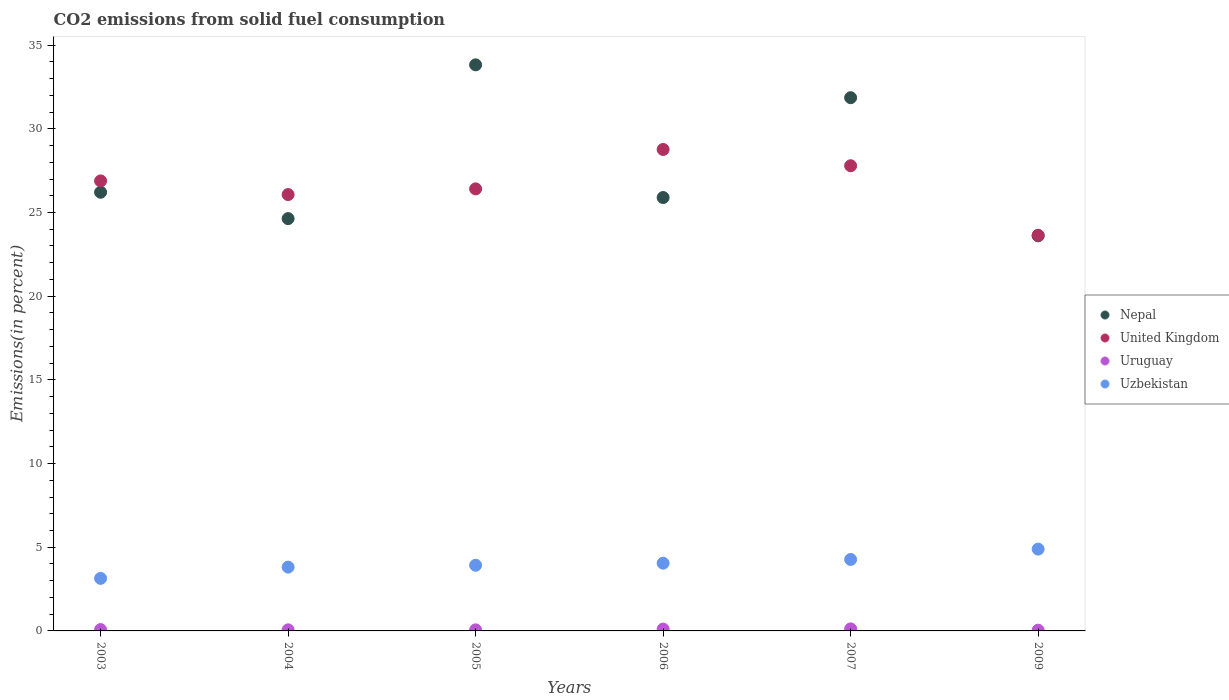Is the number of dotlines equal to the number of legend labels?
Your answer should be compact. Yes. What is the total CO2 emitted in Uzbekistan in 2005?
Your response must be concise. 3.92. Across all years, what is the maximum total CO2 emitted in Uruguay?
Give a very brief answer. 0.12. Across all years, what is the minimum total CO2 emitted in United Kingdom?
Ensure brevity in your answer.  23.64. In which year was the total CO2 emitted in United Kingdom maximum?
Keep it short and to the point. 2006. What is the total total CO2 emitted in Nepal in the graph?
Make the answer very short. 166.03. What is the difference between the total CO2 emitted in United Kingdom in 2003 and that in 2007?
Your answer should be very brief. -0.91. What is the difference between the total CO2 emitted in United Kingdom in 2006 and the total CO2 emitted in Uzbekistan in 2003?
Offer a terse response. 25.63. What is the average total CO2 emitted in Uruguay per year?
Give a very brief answer. 0.08. In the year 2009, what is the difference between the total CO2 emitted in Uzbekistan and total CO2 emitted in Uruguay?
Your response must be concise. 4.84. In how many years, is the total CO2 emitted in United Kingdom greater than 25 %?
Offer a very short reply. 5. What is the ratio of the total CO2 emitted in United Kingdom in 2004 to that in 2006?
Give a very brief answer. 0.91. Is the total CO2 emitted in Uzbekistan in 2004 less than that in 2009?
Your response must be concise. Yes. What is the difference between the highest and the second highest total CO2 emitted in Uruguay?
Offer a terse response. 0.01. What is the difference between the highest and the lowest total CO2 emitted in Uruguay?
Your response must be concise. 0.08. In how many years, is the total CO2 emitted in Uruguay greater than the average total CO2 emitted in Uruguay taken over all years?
Keep it short and to the point. 2. Is it the case that in every year, the sum of the total CO2 emitted in United Kingdom and total CO2 emitted in Uruguay  is greater than the sum of total CO2 emitted in Uzbekistan and total CO2 emitted in Nepal?
Offer a very short reply. Yes. Is the total CO2 emitted in Uruguay strictly greater than the total CO2 emitted in Uzbekistan over the years?
Offer a terse response. No. Is the total CO2 emitted in Uzbekistan strictly less than the total CO2 emitted in Nepal over the years?
Your response must be concise. Yes. How many dotlines are there?
Keep it short and to the point. 4. How many years are there in the graph?
Your answer should be compact. 6. Does the graph contain any zero values?
Provide a short and direct response. No. What is the title of the graph?
Your answer should be very brief. CO2 emissions from solid fuel consumption. What is the label or title of the Y-axis?
Offer a terse response. Emissions(in percent). What is the Emissions(in percent) in Nepal in 2003?
Your answer should be very brief. 26.21. What is the Emissions(in percent) of United Kingdom in 2003?
Your response must be concise. 26.89. What is the Emissions(in percent) in Uruguay in 2003?
Give a very brief answer. 0.08. What is the Emissions(in percent) in Uzbekistan in 2003?
Provide a short and direct response. 3.14. What is the Emissions(in percent) of Nepal in 2004?
Give a very brief answer. 24.64. What is the Emissions(in percent) of United Kingdom in 2004?
Ensure brevity in your answer.  26.07. What is the Emissions(in percent) in Uruguay in 2004?
Your answer should be compact. 0.07. What is the Emissions(in percent) of Uzbekistan in 2004?
Provide a short and direct response. 3.81. What is the Emissions(in percent) of Nepal in 2005?
Your answer should be very brief. 33.82. What is the Emissions(in percent) of United Kingdom in 2005?
Provide a short and direct response. 26.41. What is the Emissions(in percent) in Uruguay in 2005?
Make the answer very short. 0.06. What is the Emissions(in percent) of Uzbekistan in 2005?
Provide a short and direct response. 3.92. What is the Emissions(in percent) of Nepal in 2006?
Your answer should be very brief. 25.9. What is the Emissions(in percent) in United Kingdom in 2006?
Give a very brief answer. 28.77. What is the Emissions(in percent) in Uruguay in 2006?
Provide a short and direct response. 0.11. What is the Emissions(in percent) in Uzbekistan in 2006?
Offer a terse response. 4.05. What is the Emissions(in percent) of Nepal in 2007?
Provide a succinct answer. 31.86. What is the Emissions(in percent) in United Kingdom in 2007?
Give a very brief answer. 27.79. What is the Emissions(in percent) in Uruguay in 2007?
Provide a short and direct response. 0.12. What is the Emissions(in percent) of Uzbekistan in 2007?
Your response must be concise. 4.27. What is the Emissions(in percent) in Nepal in 2009?
Keep it short and to the point. 23.61. What is the Emissions(in percent) in United Kingdom in 2009?
Make the answer very short. 23.64. What is the Emissions(in percent) of Uruguay in 2009?
Ensure brevity in your answer.  0.05. What is the Emissions(in percent) of Uzbekistan in 2009?
Give a very brief answer. 4.89. Across all years, what is the maximum Emissions(in percent) in Nepal?
Your answer should be compact. 33.82. Across all years, what is the maximum Emissions(in percent) in United Kingdom?
Offer a terse response. 28.77. Across all years, what is the maximum Emissions(in percent) of Uruguay?
Your response must be concise. 0.12. Across all years, what is the maximum Emissions(in percent) of Uzbekistan?
Provide a succinct answer. 4.89. Across all years, what is the minimum Emissions(in percent) in Nepal?
Provide a short and direct response. 23.61. Across all years, what is the minimum Emissions(in percent) in United Kingdom?
Offer a terse response. 23.64. Across all years, what is the minimum Emissions(in percent) of Uruguay?
Give a very brief answer. 0.05. Across all years, what is the minimum Emissions(in percent) in Uzbekistan?
Provide a succinct answer. 3.14. What is the total Emissions(in percent) in Nepal in the graph?
Give a very brief answer. 166.03. What is the total Emissions(in percent) in United Kingdom in the graph?
Provide a succinct answer. 159.58. What is the total Emissions(in percent) in Uruguay in the graph?
Ensure brevity in your answer.  0.49. What is the total Emissions(in percent) of Uzbekistan in the graph?
Make the answer very short. 24.08. What is the difference between the Emissions(in percent) in Nepal in 2003 and that in 2004?
Provide a short and direct response. 1.58. What is the difference between the Emissions(in percent) in United Kingdom in 2003 and that in 2004?
Your answer should be compact. 0.82. What is the difference between the Emissions(in percent) in Uruguay in 2003 and that in 2004?
Provide a short and direct response. 0.01. What is the difference between the Emissions(in percent) in Uzbekistan in 2003 and that in 2004?
Ensure brevity in your answer.  -0.67. What is the difference between the Emissions(in percent) of Nepal in 2003 and that in 2005?
Your answer should be very brief. -7.61. What is the difference between the Emissions(in percent) of United Kingdom in 2003 and that in 2005?
Keep it short and to the point. 0.48. What is the difference between the Emissions(in percent) in Uruguay in 2003 and that in 2005?
Give a very brief answer. 0.02. What is the difference between the Emissions(in percent) in Uzbekistan in 2003 and that in 2005?
Offer a very short reply. -0.78. What is the difference between the Emissions(in percent) of Nepal in 2003 and that in 2006?
Make the answer very short. 0.32. What is the difference between the Emissions(in percent) of United Kingdom in 2003 and that in 2006?
Make the answer very short. -1.88. What is the difference between the Emissions(in percent) in Uruguay in 2003 and that in 2006?
Offer a terse response. -0.03. What is the difference between the Emissions(in percent) in Uzbekistan in 2003 and that in 2006?
Make the answer very short. -0.91. What is the difference between the Emissions(in percent) of Nepal in 2003 and that in 2007?
Make the answer very short. -5.65. What is the difference between the Emissions(in percent) of United Kingdom in 2003 and that in 2007?
Keep it short and to the point. -0.91. What is the difference between the Emissions(in percent) in Uruguay in 2003 and that in 2007?
Your answer should be compact. -0.04. What is the difference between the Emissions(in percent) in Uzbekistan in 2003 and that in 2007?
Your response must be concise. -1.13. What is the difference between the Emissions(in percent) in Nepal in 2003 and that in 2009?
Your answer should be compact. 2.6. What is the difference between the Emissions(in percent) in United Kingdom in 2003 and that in 2009?
Give a very brief answer. 3.25. What is the difference between the Emissions(in percent) of Uruguay in 2003 and that in 2009?
Give a very brief answer. 0.03. What is the difference between the Emissions(in percent) of Uzbekistan in 2003 and that in 2009?
Provide a short and direct response. -1.75. What is the difference between the Emissions(in percent) of Nepal in 2004 and that in 2005?
Your answer should be compact. -9.19. What is the difference between the Emissions(in percent) in United Kingdom in 2004 and that in 2005?
Offer a very short reply. -0.34. What is the difference between the Emissions(in percent) in Uruguay in 2004 and that in 2005?
Keep it short and to the point. 0. What is the difference between the Emissions(in percent) of Uzbekistan in 2004 and that in 2005?
Your response must be concise. -0.11. What is the difference between the Emissions(in percent) of Nepal in 2004 and that in 2006?
Give a very brief answer. -1.26. What is the difference between the Emissions(in percent) of United Kingdom in 2004 and that in 2006?
Offer a very short reply. -2.69. What is the difference between the Emissions(in percent) in Uruguay in 2004 and that in 2006?
Provide a succinct answer. -0.04. What is the difference between the Emissions(in percent) in Uzbekistan in 2004 and that in 2006?
Provide a succinct answer. -0.23. What is the difference between the Emissions(in percent) in Nepal in 2004 and that in 2007?
Give a very brief answer. -7.22. What is the difference between the Emissions(in percent) of United Kingdom in 2004 and that in 2007?
Keep it short and to the point. -1.72. What is the difference between the Emissions(in percent) in Uruguay in 2004 and that in 2007?
Your response must be concise. -0.06. What is the difference between the Emissions(in percent) in Uzbekistan in 2004 and that in 2007?
Provide a short and direct response. -0.46. What is the difference between the Emissions(in percent) of Nepal in 2004 and that in 2009?
Make the answer very short. 1.03. What is the difference between the Emissions(in percent) of United Kingdom in 2004 and that in 2009?
Make the answer very short. 2.43. What is the difference between the Emissions(in percent) in Uruguay in 2004 and that in 2009?
Your answer should be very brief. 0.02. What is the difference between the Emissions(in percent) of Uzbekistan in 2004 and that in 2009?
Offer a very short reply. -1.08. What is the difference between the Emissions(in percent) of Nepal in 2005 and that in 2006?
Offer a very short reply. 7.93. What is the difference between the Emissions(in percent) of United Kingdom in 2005 and that in 2006?
Give a very brief answer. -2.35. What is the difference between the Emissions(in percent) in Uruguay in 2005 and that in 2006?
Provide a succinct answer. -0.05. What is the difference between the Emissions(in percent) of Uzbekistan in 2005 and that in 2006?
Offer a very short reply. -0.12. What is the difference between the Emissions(in percent) in Nepal in 2005 and that in 2007?
Your response must be concise. 1.96. What is the difference between the Emissions(in percent) in United Kingdom in 2005 and that in 2007?
Provide a short and direct response. -1.38. What is the difference between the Emissions(in percent) of Uruguay in 2005 and that in 2007?
Your answer should be very brief. -0.06. What is the difference between the Emissions(in percent) of Uzbekistan in 2005 and that in 2007?
Give a very brief answer. -0.35. What is the difference between the Emissions(in percent) in Nepal in 2005 and that in 2009?
Offer a terse response. 10.22. What is the difference between the Emissions(in percent) in United Kingdom in 2005 and that in 2009?
Give a very brief answer. 2.77. What is the difference between the Emissions(in percent) in Uruguay in 2005 and that in 2009?
Offer a very short reply. 0.02. What is the difference between the Emissions(in percent) in Uzbekistan in 2005 and that in 2009?
Keep it short and to the point. -0.96. What is the difference between the Emissions(in percent) of Nepal in 2006 and that in 2007?
Offer a very short reply. -5.97. What is the difference between the Emissions(in percent) of United Kingdom in 2006 and that in 2007?
Your response must be concise. 0.97. What is the difference between the Emissions(in percent) of Uruguay in 2006 and that in 2007?
Offer a very short reply. -0.01. What is the difference between the Emissions(in percent) of Uzbekistan in 2006 and that in 2007?
Give a very brief answer. -0.22. What is the difference between the Emissions(in percent) of Nepal in 2006 and that in 2009?
Provide a succinct answer. 2.29. What is the difference between the Emissions(in percent) in United Kingdom in 2006 and that in 2009?
Offer a very short reply. 5.13. What is the difference between the Emissions(in percent) in Uruguay in 2006 and that in 2009?
Provide a succinct answer. 0.06. What is the difference between the Emissions(in percent) in Uzbekistan in 2006 and that in 2009?
Provide a short and direct response. -0.84. What is the difference between the Emissions(in percent) in Nepal in 2007 and that in 2009?
Give a very brief answer. 8.25. What is the difference between the Emissions(in percent) of United Kingdom in 2007 and that in 2009?
Your answer should be compact. 4.15. What is the difference between the Emissions(in percent) in Uruguay in 2007 and that in 2009?
Your answer should be very brief. 0.08. What is the difference between the Emissions(in percent) in Uzbekistan in 2007 and that in 2009?
Ensure brevity in your answer.  -0.62. What is the difference between the Emissions(in percent) in Nepal in 2003 and the Emissions(in percent) in United Kingdom in 2004?
Keep it short and to the point. 0.14. What is the difference between the Emissions(in percent) of Nepal in 2003 and the Emissions(in percent) of Uruguay in 2004?
Make the answer very short. 26.15. What is the difference between the Emissions(in percent) in Nepal in 2003 and the Emissions(in percent) in Uzbekistan in 2004?
Offer a terse response. 22.4. What is the difference between the Emissions(in percent) in United Kingdom in 2003 and the Emissions(in percent) in Uruguay in 2004?
Your answer should be compact. 26.82. What is the difference between the Emissions(in percent) of United Kingdom in 2003 and the Emissions(in percent) of Uzbekistan in 2004?
Offer a terse response. 23.08. What is the difference between the Emissions(in percent) in Uruguay in 2003 and the Emissions(in percent) in Uzbekistan in 2004?
Your answer should be very brief. -3.73. What is the difference between the Emissions(in percent) of Nepal in 2003 and the Emissions(in percent) of United Kingdom in 2005?
Your answer should be compact. -0.2. What is the difference between the Emissions(in percent) in Nepal in 2003 and the Emissions(in percent) in Uruguay in 2005?
Ensure brevity in your answer.  26.15. What is the difference between the Emissions(in percent) of Nepal in 2003 and the Emissions(in percent) of Uzbekistan in 2005?
Make the answer very short. 22.29. What is the difference between the Emissions(in percent) in United Kingdom in 2003 and the Emissions(in percent) in Uruguay in 2005?
Provide a succinct answer. 26.82. What is the difference between the Emissions(in percent) of United Kingdom in 2003 and the Emissions(in percent) of Uzbekistan in 2005?
Your answer should be very brief. 22.96. What is the difference between the Emissions(in percent) in Uruguay in 2003 and the Emissions(in percent) in Uzbekistan in 2005?
Keep it short and to the point. -3.84. What is the difference between the Emissions(in percent) in Nepal in 2003 and the Emissions(in percent) in United Kingdom in 2006?
Your answer should be compact. -2.56. What is the difference between the Emissions(in percent) in Nepal in 2003 and the Emissions(in percent) in Uruguay in 2006?
Provide a short and direct response. 26.1. What is the difference between the Emissions(in percent) of Nepal in 2003 and the Emissions(in percent) of Uzbekistan in 2006?
Give a very brief answer. 22.16. What is the difference between the Emissions(in percent) of United Kingdom in 2003 and the Emissions(in percent) of Uruguay in 2006?
Offer a terse response. 26.78. What is the difference between the Emissions(in percent) of United Kingdom in 2003 and the Emissions(in percent) of Uzbekistan in 2006?
Ensure brevity in your answer.  22.84. What is the difference between the Emissions(in percent) of Uruguay in 2003 and the Emissions(in percent) of Uzbekistan in 2006?
Your answer should be compact. -3.97. What is the difference between the Emissions(in percent) of Nepal in 2003 and the Emissions(in percent) of United Kingdom in 2007?
Your answer should be very brief. -1.58. What is the difference between the Emissions(in percent) of Nepal in 2003 and the Emissions(in percent) of Uruguay in 2007?
Give a very brief answer. 26.09. What is the difference between the Emissions(in percent) of Nepal in 2003 and the Emissions(in percent) of Uzbekistan in 2007?
Provide a succinct answer. 21.94. What is the difference between the Emissions(in percent) in United Kingdom in 2003 and the Emissions(in percent) in Uruguay in 2007?
Offer a very short reply. 26.77. What is the difference between the Emissions(in percent) of United Kingdom in 2003 and the Emissions(in percent) of Uzbekistan in 2007?
Your response must be concise. 22.62. What is the difference between the Emissions(in percent) of Uruguay in 2003 and the Emissions(in percent) of Uzbekistan in 2007?
Offer a terse response. -4.19. What is the difference between the Emissions(in percent) in Nepal in 2003 and the Emissions(in percent) in United Kingdom in 2009?
Your answer should be very brief. 2.57. What is the difference between the Emissions(in percent) in Nepal in 2003 and the Emissions(in percent) in Uruguay in 2009?
Ensure brevity in your answer.  26.17. What is the difference between the Emissions(in percent) in Nepal in 2003 and the Emissions(in percent) in Uzbekistan in 2009?
Offer a terse response. 21.32. What is the difference between the Emissions(in percent) in United Kingdom in 2003 and the Emissions(in percent) in Uruguay in 2009?
Your answer should be very brief. 26.84. What is the difference between the Emissions(in percent) in United Kingdom in 2003 and the Emissions(in percent) in Uzbekistan in 2009?
Provide a short and direct response. 22. What is the difference between the Emissions(in percent) of Uruguay in 2003 and the Emissions(in percent) of Uzbekistan in 2009?
Offer a terse response. -4.81. What is the difference between the Emissions(in percent) of Nepal in 2004 and the Emissions(in percent) of United Kingdom in 2005?
Offer a very short reply. -1.78. What is the difference between the Emissions(in percent) in Nepal in 2004 and the Emissions(in percent) in Uruguay in 2005?
Your answer should be compact. 24.57. What is the difference between the Emissions(in percent) in Nepal in 2004 and the Emissions(in percent) in Uzbekistan in 2005?
Keep it short and to the point. 20.71. What is the difference between the Emissions(in percent) of United Kingdom in 2004 and the Emissions(in percent) of Uruguay in 2005?
Offer a terse response. 26.01. What is the difference between the Emissions(in percent) in United Kingdom in 2004 and the Emissions(in percent) in Uzbekistan in 2005?
Offer a very short reply. 22.15. What is the difference between the Emissions(in percent) of Uruguay in 2004 and the Emissions(in percent) of Uzbekistan in 2005?
Your answer should be very brief. -3.86. What is the difference between the Emissions(in percent) in Nepal in 2004 and the Emissions(in percent) in United Kingdom in 2006?
Keep it short and to the point. -4.13. What is the difference between the Emissions(in percent) of Nepal in 2004 and the Emissions(in percent) of Uruguay in 2006?
Your answer should be compact. 24.53. What is the difference between the Emissions(in percent) in Nepal in 2004 and the Emissions(in percent) in Uzbekistan in 2006?
Your answer should be very brief. 20.59. What is the difference between the Emissions(in percent) of United Kingdom in 2004 and the Emissions(in percent) of Uruguay in 2006?
Your answer should be compact. 25.96. What is the difference between the Emissions(in percent) of United Kingdom in 2004 and the Emissions(in percent) of Uzbekistan in 2006?
Keep it short and to the point. 22.03. What is the difference between the Emissions(in percent) in Uruguay in 2004 and the Emissions(in percent) in Uzbekistan in 2006?
Provide a succinct answer. -3.98. What is the difference between the Emissions(in percent) in Nepal in 2004 and the Emissions(in percent) in United Kingdom in 2007?
Keep it short and to the point. -3.16. What is the difference between the Emissions(in percent) in Nepal in 2004 and the Emissions(in percent) in Uruguay in 2007?
Offer a very short reply. 24.51. What is the difference between the Emissions(in percent) in Nepal in 2004 and the Emissions(in percent) in Uzbekistan in 2007?
Give a very brief answer. 20.37. What is the difference between the Emissions(in percent) of United Kingdom in 2004 and the Emissions(in percent) of Uruguay in 2007?
Make the answer very short. 25.95. What is the difference between the Emissions(in percent) in United Kingdom in 2004 and the Emissions(in percent) in Uzbekistan in 2007?
Your response must be concise. 21.8. What is the difference between the Emissions(in percent) of Uruguay in 2004 and the Emissions(in percent) of Uzbekistan in 2007?
Your response must be concise. -4.2. What is the difference between the Emissions(in percent) of Nepal in 2004 and the Emissions(in percent) of United Kingdom in 2009?
Keep it short and to the point. 0.99. What is the difference between the Emissions(in percent) of Nepal in 2004 and the Emissions(in percent) of Uruguay in 2009?
Keep it short and to the point. 24.59. What is the difference between the Emissions(in percent) in Nepal in 2004 and the Emissions(in percent) in Uzbekistan in 2009?
Offer a terse response. 19.75. What is the difference between the Emissions(in percent) of United Kingdom in 2004 and the Emissions(in percent) of Uruguay in 2009?
Ensure brevity in your answer.  26.03. What is the difference between the Emissions(in percent) of United Kingdom in 2004 and the Emissions(in percent) of Uzbekistan in 2009?
Your answer should be very brief. 21.18. What is the difference between the Emissions(in percent) of Uruguay in 2004 and the Emissions(in percent) of Uzbekistan in 2009?
Ensure brevity in your answer.  -4.82. What is the difference between the Emissions(in percent) of Nepal in 2005 and the Emissions(in percent) of United Kingdom in 2006?
Ensure brevity in your answer.  5.06. What is the difference between the Emissions(in percent) in Nepal in 2005 and the Emissions(in percent) in Uruguay in 2006?
Give a very brief answer. 33.71. What is the difference between the Emissions(in percent) of Nepal in 2005 and the Emissions(in percent) of Uzbekistan in 2006?
Keep it short and to the point. 29.78. What is the difference between the Emissions(in percent) in United Kingdom in 2005 and the Emissions(in percent) in Uruguay in 2006?
Your answer should be compact. 26.3. What is the difference between the Emissions(in percent) in United Kingdom in 2005 and the Emissions(in percent) in Uzbekistan in 2006?
Keep it short and to the point. 22.37. What is the difference between the Emissions(in percent) of Uruguay in 2005 and the Emissions(in percent) of Uzbekistan in 2006?
Offer a terse response. -3.98. What is the difference between the Emissions(in percent) of Nepal in 2005 and the Emissions(in percent) of United Kingdom in 2007?
Your answer should be compact. 6.03. What is the difference between the Emissions(in percent) of Nepal in 2005 and the Emissions(in percent) of Uruguay in 2007?
Offer a terse response. 33.7. What is the difference between the Emissions(in percent) in Nepal in 2005 and the Emissions(in percent) in Uzbekistan in 2007?
Make the answer very short. 29.55. What is the difference between the Emissions(in percent) in United Kingdom in 2005 and the Emissions(in percent) in Uruguay in 2007?
Offer a terse response. 26.29. What is the difference between the Emissions(in percent) of United Kingdom in 2005 and the Emissions(in percent) of Uzbekistan in 2007?
Give a very brief answer. 22.14. What is the difference between the Emissions(in percent) of Uruguay in 2005 and the Emissions(in percent) of Uzbekistan in 2007?
Make the answer very short. -4.21. What is the difference between the Emissions(in percent) in Nepal in 2005 and the Emissions(in percent) in United Kingdom in 2009?
Your response must be concise. 10.18. What is the difference between the Emissions(in percent) in Nepal in 2005 and the Emissions(in percent) in Uruguay in 2009?
Make the answer very short. 33.78. What is the difference between the Emissions(in percent) of Nepal in 2005 and the Emissions(in percent) of Uzbekistan in 2009?
Offer a terse response. 28.94. What is the difference between the Emissions(in percent) of United Kingdom in 2005 and the Emissions(in percent) of Uruguay in 2009?
Provide a succinct answer. 26.37. What is the difference between the Emissions(in percent) in United Kingdom in 2005 and the Emissions(in percent) in Uzbekistan in 2009?
Ensure brevity in your answer.  21.52. What is the difference between the Emissions(in percent) of Uruguay in 2005 and the Emissions(in percent) of Uzbekistan in 2009?
Make the answer very short. -4.82. What is the difference between the Emissions(in percent) in Nepal in 2006 and the Emissions(in percent) in United Kingdom in 2007?
Your answer should be very brief. -1.9. What is the difference between the Emissions(in percent) in Nepal in 2006 and the Emissions(in percent) in Uruguay in 2007?
Keep it short and to the point. 25.77. What is the difference between the Emissions(in percent) in Nepal in 2006 and the Emissions(in percent) in Uzbekistan in 2007?
Offer a very short reply. 21.63. What is the difference between the Emissions(in percent) in United Kingdom in 2006 and the Emissions(in percent) in Uruguay in 2007?
Offer a terse response. 28.64. What is the difference between the Emissions(in percent) of United Kingdom in 2006 and the Emissions(in percent) of Uzbekistan in 2007?
Give a very brief answer. 24.5. What is the difference between the Emissions(in percent) in Uruguay in 2006 and the Emissions(in percent) in Uzbekistan in 2007?
Offer a terse response. -4.16. What is the difference between the Emissions(in percent) in Nepal in 2006 and the Emissions(in percent) in United Kingdom in 2009?
Your response must be concise. 2.25. What is the difference between the Emissions(in percent) in Nepal in 2006 and the Emissions(in percent) in Uruguay in 2009?
Your response must be concise. 25.85. What is the difference between the Emissions(in percent) in Nepal in 2006 and the Emissions(in percent) in Uzbekistan in 2009?
Offer a terse response. 21.01. What is the difference between the Emissions(in percent) of United Kingdom in 2006 and the Emissions(in percent) of Uruguay in 2009?
Make the answer very short. 28.72. What is the difference between the Emissions(in percent) of United Kingdom in 2006 and the Emissions(in percent) of Uzbekistan in 2009?
Your answer should be very brief. 23.88. What is the difference between the Emissions(in percent) of Uruguay in 2006 and the Emissions(in percent) of Uzbekistan in 2009?
Keep it short and to the point. -4.78. What is the difference between the Emissions(in percent) in Nepal in 2007 and the Emissions(in percent) in United Kingdom in 2009?
Make the answer very short. 8.22. What is the difference between the Emissions(in percent) in Nepal in 2007 and the Emissions(in percent) in Uruguay in 2009?
Keep it short and to the point. 31.82. What is the difference between the Emissions(in percent) of Nepal in 2007 and the Emissions(in percent) of Uzbekistan in 2009?
Provide a succinct answer. 26.97. What is the difference between the Emissions(in percent) in United Kingdom in 2007 and the Emissions(in percent) in Uruguay in 2009?
Offer a terse response. 27.75. What is the difference between the Emissions(in percent) of United Kingdom in 2007 and the Emissions(in percent) of Uzbekistan in 2009?
Provide a short and direct response. 22.91. What is the difference between the Emissions(in percent) of Uruguay in 2007 and the Emissions(in percent) of Uzbekistan in 2009?
Provide a short and direct response. -4.77. What is the average Emissions(in percent) of Nepal per year?
Your response must be concise. 27.67. What is the average Emissions(in percent) in United Kingdom per year?
Offer a very short reply. 26.6. What is the average Emissions(in percent) of Uruguay per year?
Provide a succinct answer. 0.08. What is the average Emissions(in percent) in Uzbekistan per year?
Ensure brevity in your answer.  4.01. In the year 2003, what is the difference between the Emissions(in percent) in Nepal and Emissions(in percent) in United Kingdom?
Offer a very short reply. -0.68. In the year 2003, what is the difference between the Emissions(in percent) in Nepal and Emissions(in percent) in Uruguay?
Your answer should be compact. 26.13. In the year 2003, what is the difference between the Emissions(in percent) of Nepal and Emissions(in percent) of Uzbekistan?
Offer a very short reply. 23.07. In the year 2003, what is the difference between the Emissions(in percent) of United Kingdom and Emissions(in percent) of Uruguay?
Provide a succinct answer. 26.81. In the year 2003, what is the difference between the Emissions(in percent) of United Kingdom and Emissions(in percent) of Uzbekistan?
Ensure brevity in your answer.  23.75. In the year 2003, what is the difference between the Emissions(in percent) of Uruguay and Emissions(in percent) of Uzbekistan?
Offer a very short reply. -3.06. In the year 2004, what is the difference between the Emissions(in percent) of Nepal and Emissions(in percent) of United Kingdom?
Provide a succinct answer. -1.44. In the year 2004, what is the difference between the Emissions(in percent) of Nepal and Emissions(in percent) of Uruguay?
Provide a succinct answer. 24.57. In the year 2004, what is the difference between the Emissions(in percent) of Nepal and Emissions(in percent) of Uzbekistan?
Give a very brief answer. 20.82. In the year 2004, what is the difference between the Emissions(in percent) of United Kingdom and Emissions(in percent) of Uruguay?
Offer a very short reply. 26.01. In the year 2004, what is the difference between the Emissions(in percent) in United Kingdom and Emissions(in percent) in Uzbekistan?
Ensure brevity in your answer.  22.26. In the year 2004, what is the difference between the Emissions(in percent) of Uruguay and Emissions(in percent) of Uzbekistan?
Your answer should be compact. -3.75. In the year 2005, what is the difference between the Emissions(in percent) in Nepal and Emissions(in percent) in United Kingdom?
Your answer should be very brief. 7.41. In the year 2005, what is the difference between the Emissions(in percent) in Nepal and Emissions(in percent) in Uruguay?
Your response must be concise. 33.76. In the year 2005, what is the difference between the Emissions(in percent) in Nepal and Emissions(in percent) in Uzbekistan?
Provide a short and direct response. 29.9. In the year 2005, what is the difference between the Emissions(in percent) of United Kingdom and Emissions(in percent) of Uruguay?
Your answer should be compact. 26.35. In the year 2005, what is the difference between the Emissions(in percent) of United Kingdom and Emissions(in percent) of Uzbekistan?
Offer a terse response. 22.49. In the year 2005, what is the difference between the Emissions(in percent) in Uruguay and Emissions(in percent) in Uzbekistan?
Offer a terse response. -3.86. In the year 2006, what is the difference between the Emissions(in percent) in Nepal and Emissions(in percent) in United Kingdom?
Your response must be concise. -2.87. In the year 2006, what is the difference between the Emissions(in percent) of Nepal and Emissions(in percent) of Uruguay?
Offer a very short reply. 25.79. In the year 2006, what is the difference between the Emissions(in percent) of Nepal and Emissions(in percent) of Uzbekistan?
Offer a very short reply. 21.85. In the year 2006, what is the difference between the Emissions(in percent) in United Kingdom and Emissions(in percent) in Uruguay?
Keep it short and to the point. 28.66. In the year 2006, what is the difference between the Emissions(in percent) in United Kingdom and Emissions(in percent) in Uzbekistan?
Your answer should be compact. 24.72. In the year 2006, what is the difference between the Emissions(in percent) of Uruguay and Emissions(in percent) of Uzbekistan?
Your answer should be very brief. -3.94. In the year 2007, what is the difference between the Emissions(in percent) of Nepal and Emissions(in percent) of United Kingdom?
Your answer should be very brief. 4.07. In the year 2007, what is the difference between the Emissions(in percent) in Nepal and Emissions(in percent) in Uruguay?
Ensure brevity in your answer.  31.74. In the year 2007, what is the difference between the Emissions(in percent) of Nepal and Emissions(in percent) of Uzbekistan?
Your answer should be very brief. 27.59. In the year 2007, what is the difference between the Emissions(in percent) in United Kingdom and Emissions(in percent) in Uruguay?
Keep it short and to the point. 27.67. In the year 2007, what is the difference between the Emissions(in percent) of United Kingdom and Emissions(in percent) of Uzbekistan?
Give a very brief answer. 23.52. In the year 2007, what is the difference between the Emissions(in percent) of Uruguay and Emissions(in percent) of Uzbekistan?
Provide a short and direct response. -4.15. In the year 2009, what is the difference between the Emissions(in percent) in Nepal and Emissions(in percent) in United Kingdom?
Make the answer very short. -0.03. In the year 2009, what is the difference between the Emissions(in percent) in Nepal and Emissions(in percent) in Uruguay?
Offer a very short reply. 23.56. In the year 2009, what is the difference between the Emissions(in percent) in Nepal and Emissions(in percent) in Uzbekistan?
Make the answer very short. 18.72. In the year 2009, what is the difference between the Emissions(in percent) in United Kingdom and Emissions(in percent) in Uruguay?
Provide a succinct answer. 23.6. In the year 2009, what is the difference between the Emissions(in percent) of United Kingdom and Emissions(in percent) of Uzbekistan?
Ensure brevity in your answer.  18.75. In the year 2009, what is the difference between the Emissions(in percent) of Uruguay and Emissions(in percent) of Uzbekistan?
Offer a very short reply. -4.84. What is the ratio of the Emissions(in percent) in Nepal in 2003 to that in 2004?
Provide a short and direct response. 1.06. What is the ratio of the Emissions(in percent) in United Kingdom in 2003 to that in 2004?
Provide a short and direct response. 1.03. What is the ratio of the Emissions(in percent) in Uruguay in 2003 to that in 2004?
Provide a succinct answer. 1.22. What is the ratio of the Emissions(in percent) of Uzbekistan in 2003 to that in 2004?
Your response must be concise. 0.82. What is the ratio of the Emissions(in percent) of Nepal in 2003 to that in 2005?
Provide a succinct answer. 0.77. What is the ratio of the Emissions(in percent) of United Kingdom in 2003 to that in 2005?
Keep it short and to the point. 1.02. What is the ratio of the Emissions(in percent) in Uruguay in 2003 to that in 2005?
Your answer should be compact. 1.26. What is the ratio of the Emissions(in percent) of Nepal in 2003 to that in 2006?
Your response must be concise. 1.01. What is the ratio of the Emissions(in percent) of United Kingdom in 2003 to that in 2006?
Provide a succinct answer. 0.93. What is the ratio of the Emissions(in percent) in Uruguay in 2003 to that in 2006?
Your answer should be very brief. 0.72. What is the ratio of the Emissions(in percent) of Uzbekistan in 2003 to that in 2006?
Your answer should be compact. 0.78. What is the ratio of the Emissions(in percent) of Nepal in 2003 to that in 2007?
Your answer should be compact. 0.82. What is the ratio of the Emissions(in percent) in United Kingdom in 2003 to that in 2007?
Provide a succinct answer. 0.97. What is the ratio of the Emissions(in percent) of Uruguay in 2003 to that in 2007?
Provide a succinct answer. 0.65. What is the ratio of the Emissions(in percent) in Uzbekistan in 2003 to that in 2007?
Ensure brevity in your answer.  0.74. What is the ratio of the Emissions(in percent) in Nepal in 2003 to that in 2009?
Your answer should be compact. 1.11. What is the ratio of the Emissions(in percent) of United Kingdom in 2003 to that in 2009?
Provide a succinct answer. 1.14. What is the ratio of the Emissions(in percent) of Uruguay in 2003 to that in 2009?
Ensure brevity in your answer.  1.76. What is the ratio of the Emissions(in percent) in Uzbekistan in 2003 to that in 2009?
Provide a short and direct response. 0.64. What is the ratio of the Emissions(in percent) of Nepal in 2004 to that in 2005?
Provide a succinct answer. 0.73. What is the ratio of the Emissions(in percent) of United Kingdom in 2004 to that in 2005?
Your answer should be very brief. 0.99. What is the ratio of the Emissions(in percent) of Uruguay in 2004 to that in 2005?
Offer a very short reply. 1.03. What is the ratio of the Emissions(in percent) in Uzbekistan in 2004 to that in 2005?
Your answer should be compact. 0.97. What is the ratio of the Emissions(in percent) in Nepal in 2004 to that in 2006?
Keep it short and to the point. 0.95. What is the ratio of the Emissions(in percent) of United Kingdom in 2004 to that in 2006?
Offer a terse response. 0.91. What is the ratio of the Emissions(in percent) of Uruguay in 2004 to that in 2006?
Ensure brevity in your answer.  0.59. What is the ratio of the Emissions(in percent) in Uzbekistan in 2004 to that in 2006?
Offer a terse response. 0.94. What is the ratio of the Emissions(in percent) of Nepal in 2004 to that in 2007?
Provide a short and direct response. 0.77. What is the ratio of the Emissions(in percent) of United Kingdom in 2004 to that in 2007?
Offer a very short reply. 0.94. What is the ratio of the Emissions(in percent) in Uruguay in 2004 to that in 2007?
Ensure brevity in your answer.  0.53. What is the ratio of the Emissions(in percent) in Uzbekistan in 2004 to that in 2007?
Your answer should be very brief. 0.89. What is the ratio of the Emissions(in percent) of Nepal in 2004 to that in 2009?
Provide a short and direct response. 1.04. What is the ratio of the Emissions(in percent) in United Kingdom in 2004 to that in 2009?
Your answer should be compact. 1.1. What is the ratio of the Emissions(in percent) of Uruguay in 2004 to that in 2009?
Offer a very short reply. 1.44. What is the ratio of the Emissions(in percent) in Uzbekistan in 2004 to that in 2009?
Offer a terse response. 0.78. What is the ratio of the Emissions(in percent) of Nepal in 2005 to that in 2006?
Ensure brevity in your answer.  1.31. What is the ratio of the Emissions(in percent) in United Kingdom in 2005 to that in 2006?
Your response must be concise. 0.92. What is the ratio of the Emissions(in percent) of Uruguay in 2005 to that in 2006?
Provide a succinct answer. 0.58. What is the ratio of the Emissions(in percent) in Uzbekistan in 2005 to that in 2006?
Your answer should be very brief. 0.97. What is the ratio of the Emissions(in percent) in Nepal in 2005 to that in 2007?
Provide a succinct answer. 1.06. What is the ratio of the Emissions(in percent) of United Kingdom in 2005 to that in 2007?
Provide a short and direct response. 0.95. What is the ratio of the Emissions(in percent) in Uruguay in 2005 to that in 2007?
Your answer should be compact. 0.52. What is the ratio of the Emissions(in percent) in Uzbekistan in 2005 to that in 2007?
Keep it short and to the point. 0.92. What is the ratio of the Emissions(in percent) in Nepal in 2005 to that in 2009?
Keep it short and to the point. 1.43. What is the ratio of the Emissions(in percent) of United Kingdom in 2005 to that in 2009?
Make the answer very short. 1.12. What is the ratio of the Emissions(in percent) in Uruguay in 2005 to that in 2009?
Give a very brief answer. 1.4. What is the ratio of the Emissions(in percent) of Uzbekistan in 2005 to that in 2009?
Make the answer very short. 0.8. What is the ratio of the Emissions(in percent) of Nepal in 2006 to that in 2007?
Provide a succinct answer. 0.81. What is the ratio of the Emissions(in percent) of United Kingdom in 2006 to that in 2007?
Provide a succinct answer. 1.03. What is the ratio of the Emissions(in percent) in Uruguay in 2006 to that in 2007?
Provide a succinct answer. 0.9. What is the ratio of the Emissions(in percent) in Uzbekistan in 2006 to that in 2007?
Keep it short and to the point. 0.95. What is the ratio of the Emissions(in percent) in Nepal in 2006 to that in 2009?
Your answer should be compact. 1.1. What is the ratio of the Emissions(in percent) in United Kingdom in 2006 to that in 2009?
Ensure brevity in your answer.  1.22. What is the ratio of the Emissions(in percent) in Uruguay in 2006 to that in 2009?
Give a very brief answer. 2.43. What is the ratio of the Emissions(in percent) in Uzbekistan in 2006 to that in 2009?
Ensure brevity in your answer.  0.83. What is the ratio of the Emissions(in percent) in Nepal in 2007 to that in 2009?
Provide a succinct answer. 1.35. What is the ratio of the Emissions(in percent) of United Kingdom in 2007 to that in 2009?
Make the answer very short. 1.18. What is the ratio of the Emissions(in percent) in Uruguay in 2007 to that in 2009?
Offer a terse response. 2.69. What is the ratio of the Emissions(in percent) of Uzbekistan in 2007 to that in 2009?
Make the answer very short. 0.87. What is the difference between the highest and the second highest Emissions(in percent) of Nepal?
Provide a succinct answer. 1.96. What is the difference between the highest and the second highest Emissions(in percent) in United Kingdom?
Offer a very short reply. 0.97. What is the difference between the highest and the second highest Emissions(in percent) of Uruguay?
Ensure brevity in your answer.  0.01. What is the difference between the highest and the second highest Emissions(in percent) of Uzbekistan?
Your answer should be very brief. 0.62. What is the difference between the highest and the lowest Emissions(in percent) of Nepal?
Your response must be concise. 10.22. What is the difference between the highest and the lowest Emissions(in percent) of United Kingdom?
Give a very brief answer. 5.13. What is the difference between the highest and the lowest Emissions(in percent) of Uruguay?
Offer a very short reply. 0.08. What is the difference between the highest and the lowest Emissions(in percent) in Uzbekistan?
Your answer should be very brief. 1.75. 